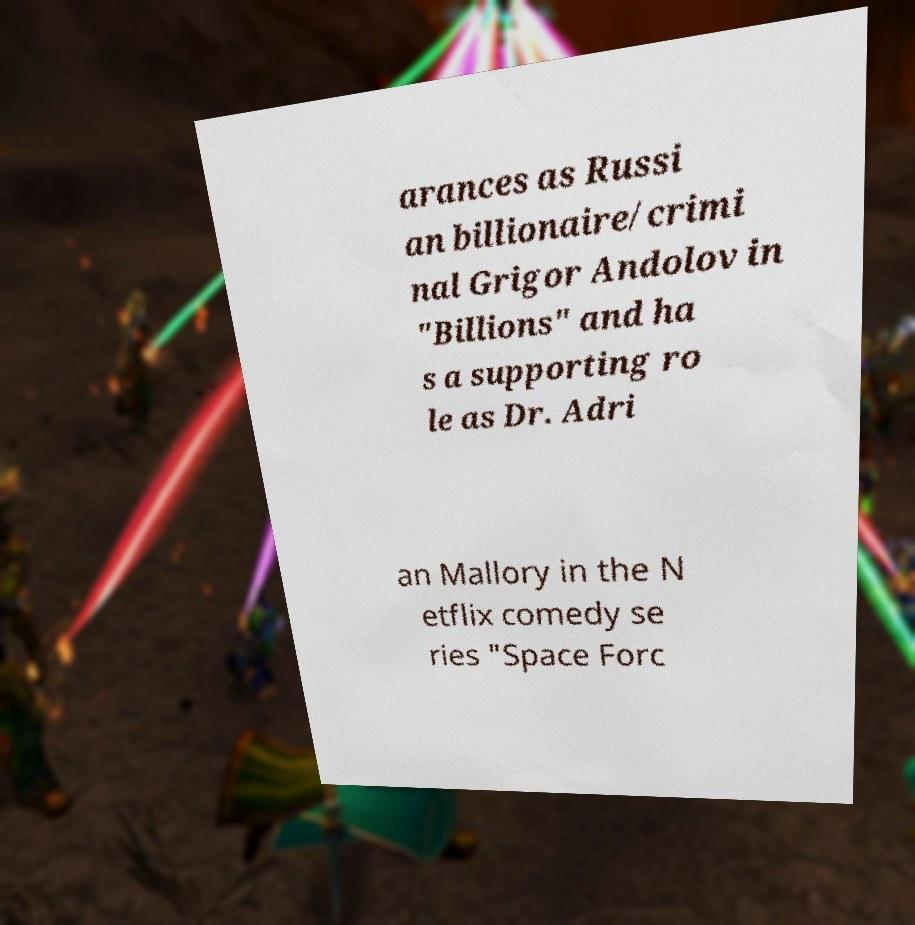There's text embedded in this image that I need extracted. Can you transcribe it verbatim? arances as Russi an billionaire/crimi nal Grigor Andolov in "Billions" and ha s a supporting ro le as Dr. Adri an Mallory in the N etflix comedy se ries "Space Forc 